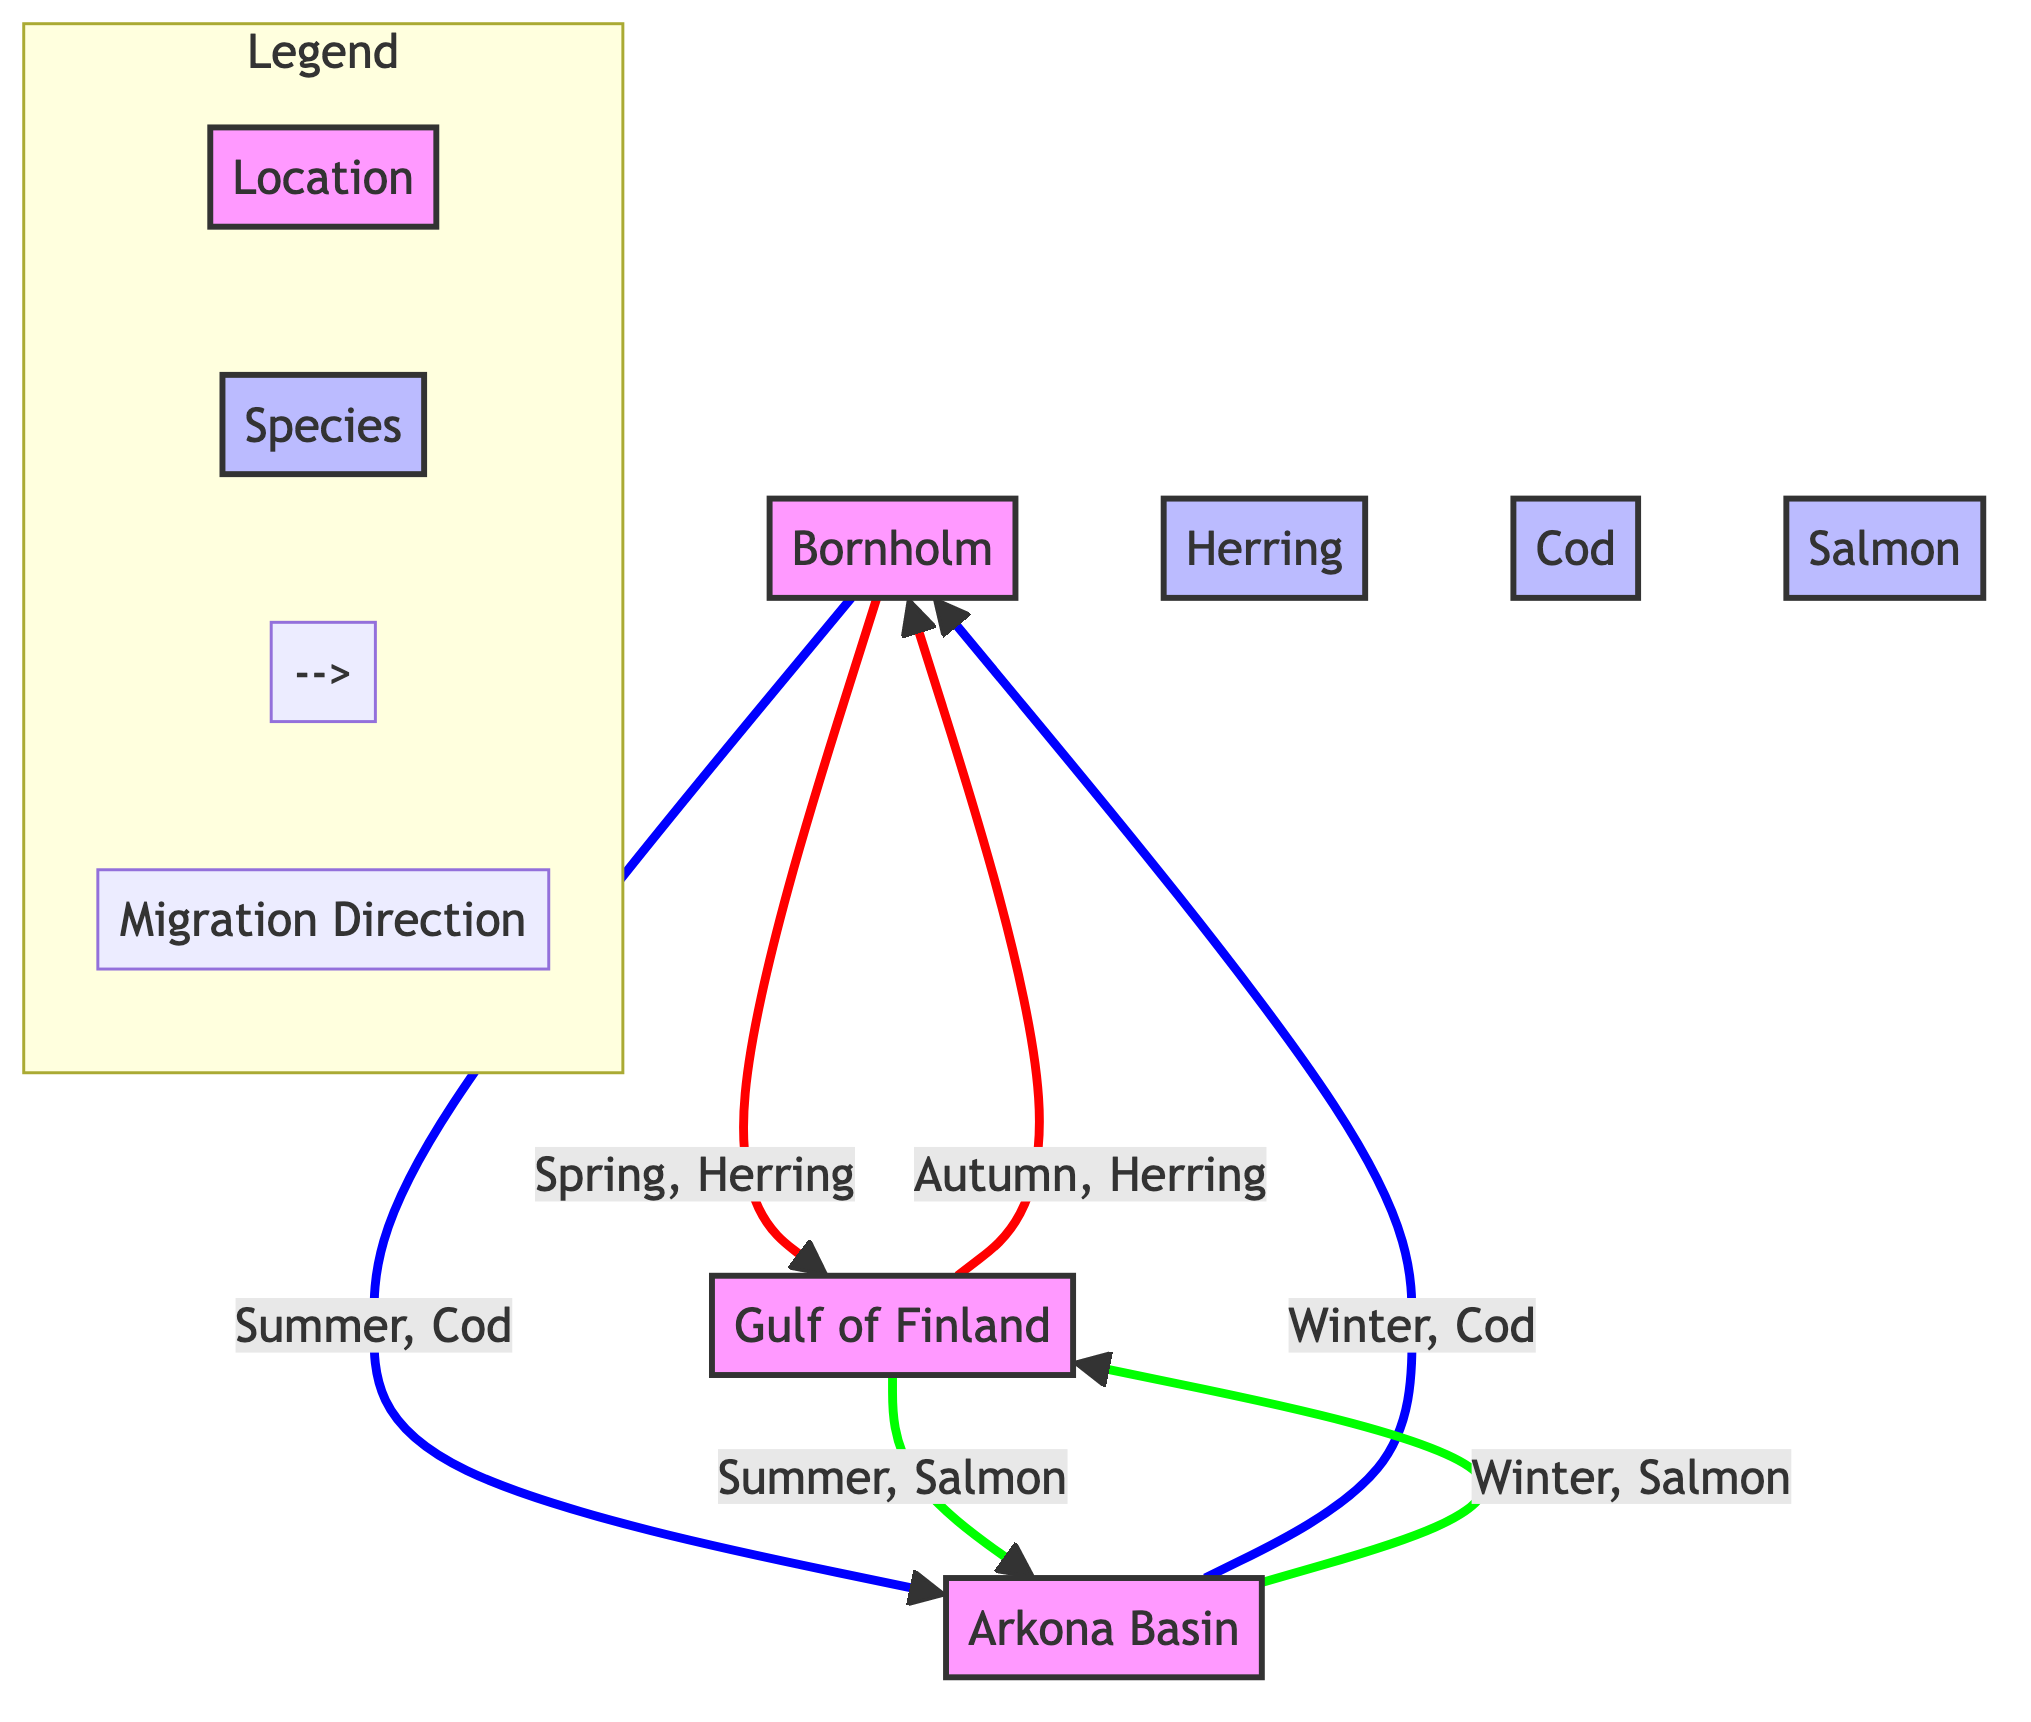What's the total number of locations in the diagram? The diagram includes three locations: Bornholm, Gulf of Finland, and Arkona Basin. By counting these locations, we find that the total is three.
Answer: 3 Which species migrate from Bornholm in Spring? According to the diagram, Herring is the species that migrates from Bornholm to the Gulf of Finland in Spring.
Answer: Herring What is the direction of Cod migration in Winter? The diagram indicates that Cod migrates from Arkona Basin to Bornholm during Winter, represented by the arrow in that direction.
Answer: Bornholm How many species are shown in the diagram? Upon examining the diagram, there are three species listed: Herring, Cod, and Salmon. Therefore, the total number of species is three.
Answer: 3 In which season does Salmon migrate to Arkona Basin? The diagram shows that Salmon migrates from Gulf of Finland to Arkona Basin in Summer, identified by the specific connection marked by the arrow.
Answer: Summer Which species migrates from Arkona Basin to Gulf of Finland in Winter? According to the diagram, Salmon migrates from Arkona Basin to Gulf of Finland during Winter, as indicated by the flow direction represented in the diagram.
Answer: Salmon How many migration routes involve Herring? The diagram illustrates two migration routes for Herring: one from Bornholm to Gulf of Finland in Spring and another from Gulf of Finland back to Bornholm in Autumn. Thus, there are two routes.
Answer: 2 What does the red color signify in the migration routes? The red color in the diagram represents migration direction specifically for Herring, which is consistent with how it is visually distinguished in the given migration patterns.
Answer: Herring What direction do Cod migrate during Summer? Based on the diagram, Cod migrates from Bornholm to Arkona Basin in Summer, evidenced by the arrow pointing from Bornholm to Arkona Basin during that season.
Answer: Arkona Basin 